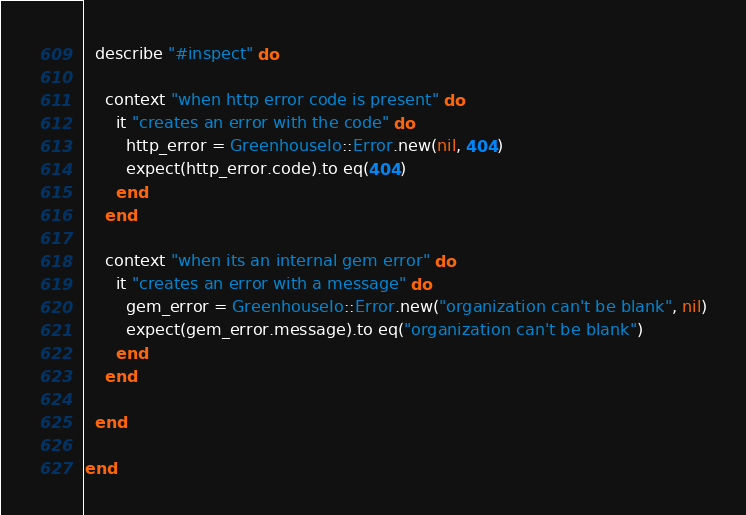Convert code to text. <code><loc_0><loc_0><loc_500><loc_500><_Ruby_>
  describe "#inspect" do

    context "when http error code is present" do
      it "creates an error with the code" do
        http_error = GreenhouseIo::Error.new(nil, 404)
        expect(http_error.code).to eq(404)
      end
    end

    context "when its an internal gem error" do
      it "creates an error with a message" do
        gem_error = GreenhouseIo::Error.new("organization can't be blank", nil)
        expect(gem_error.message).to eq("organization can't be blank")
      end
    end

  end

end
</code> 